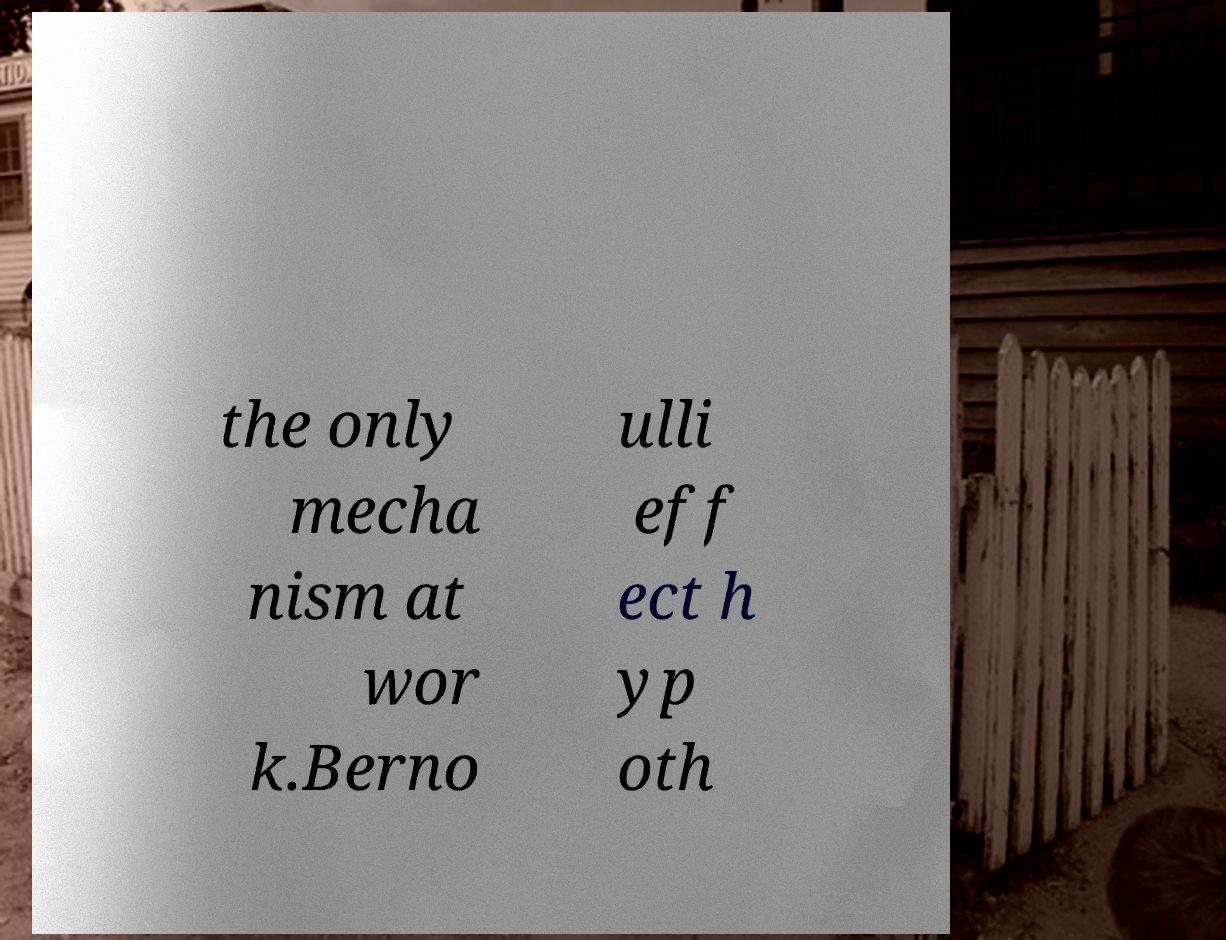What messages or text are displayed in this image? I need them in a readable, typed format. the only mecha nism at wor k.Berno ulli eff ect h yp oth 